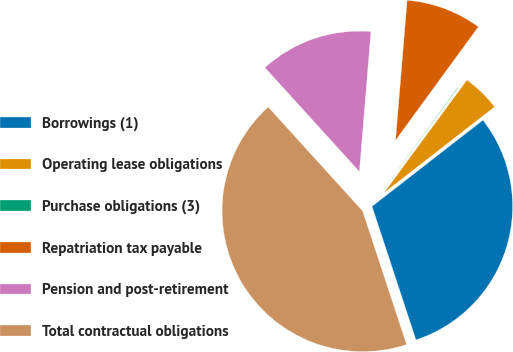Convert chart. <chart><loc_0><loc_0><loc_500><loc_500><pie_chart><fcel>Borrowings (1)<fcel>Operating lease obligations<fcel>Purchase obligations (3)<fcel>Repatriation tax payable<fcel>Pension and post-retirement<fcel>Total contractual obligations<nl><fcel>30.46%<fcel>4.39%<fcel>0.06%<fcel>8.72%<fcel>13.04%<fcel>43.33%<nl></chart> 